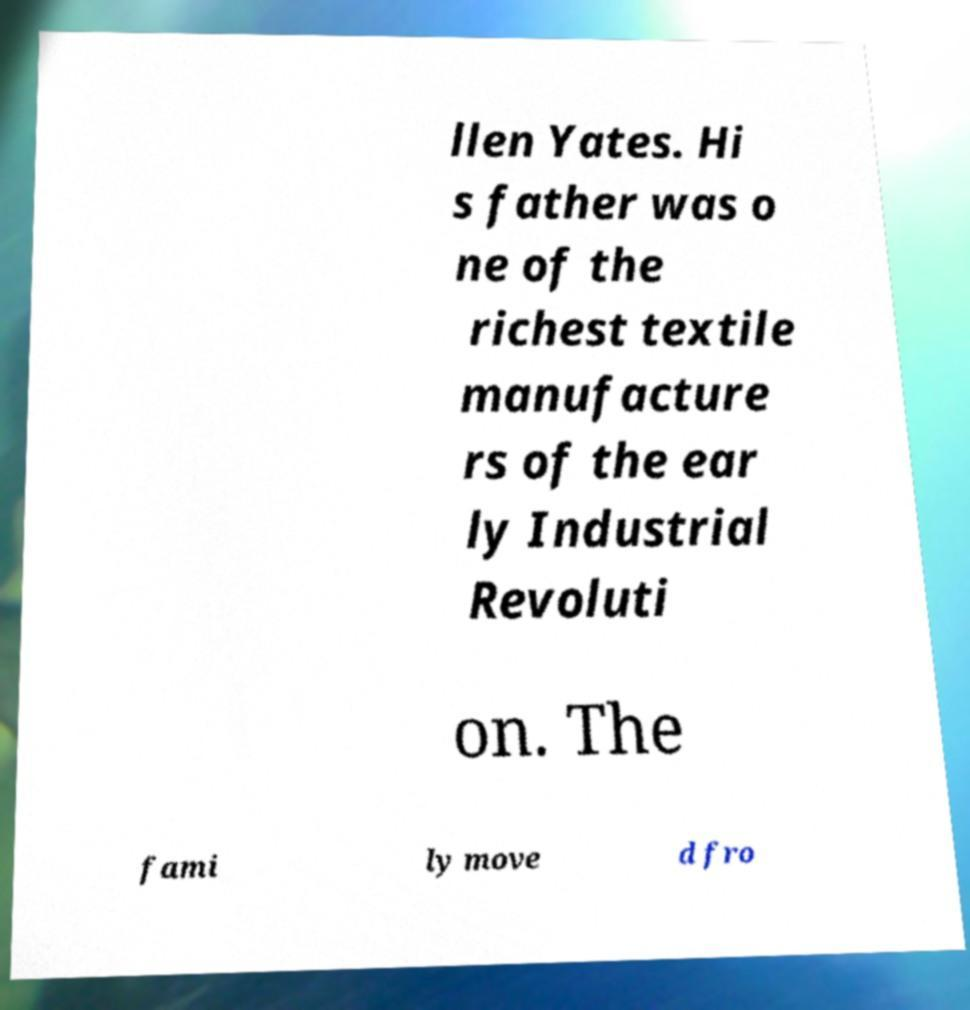I need the written content from this picture converted into text. Can you do that? llen Yates. Hi s father was o ne of the richest textile manufacture rs of the ear ly Industrial Revoluti on. The fami ly move d fro 